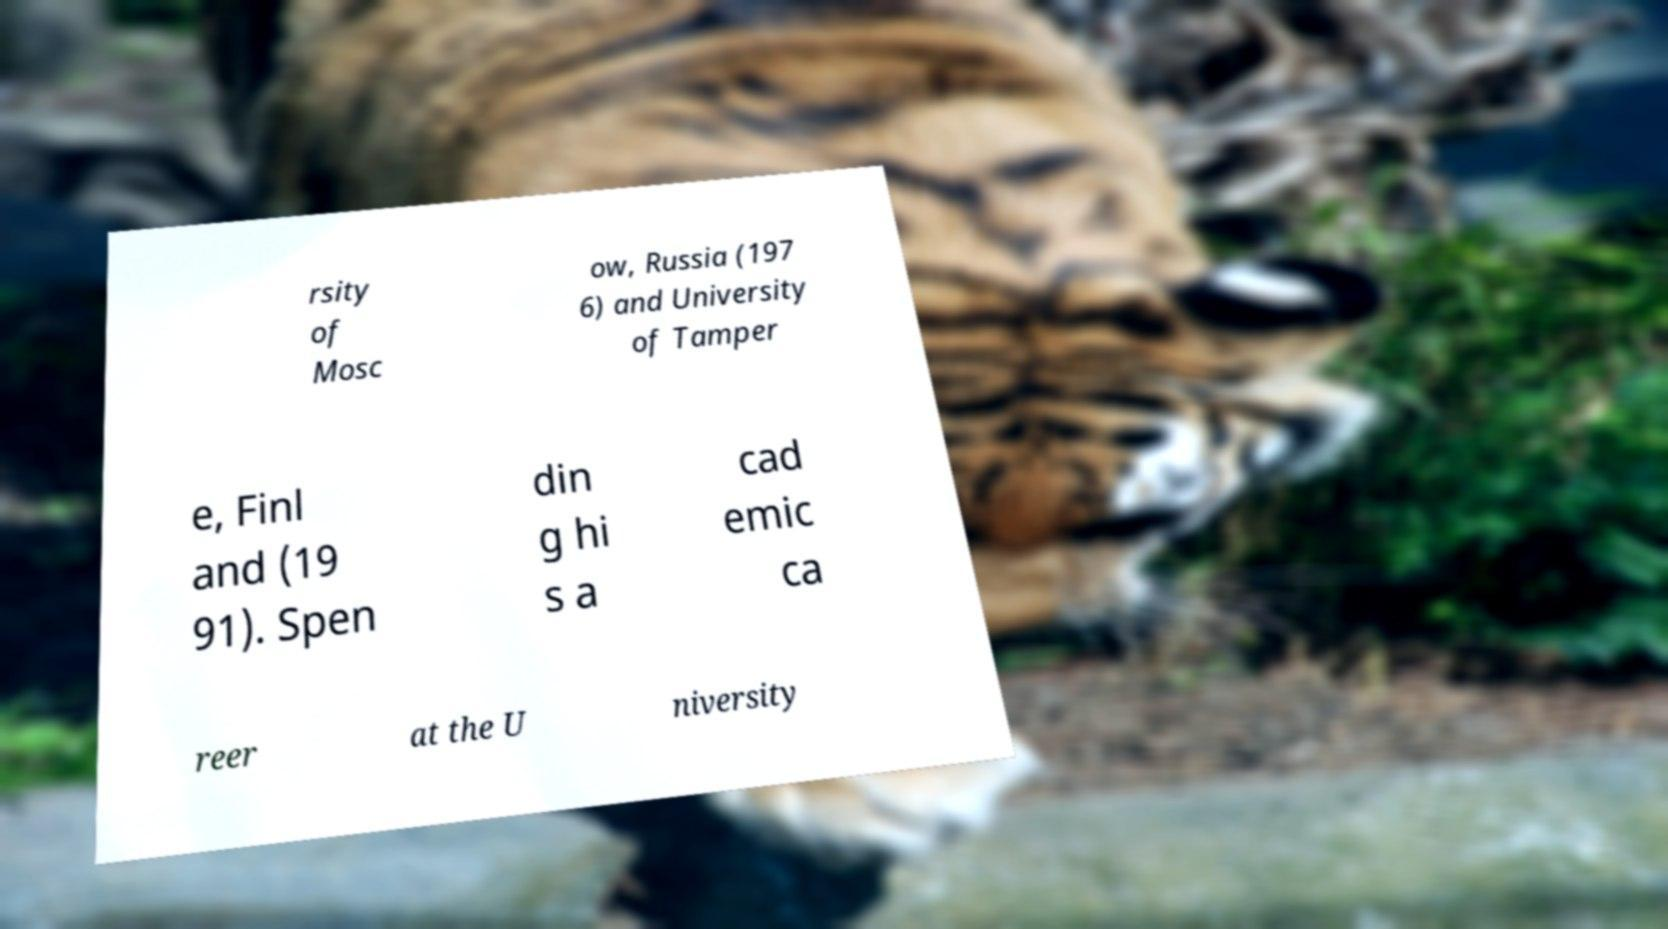What messages or text are displayed in this image? I need them in a readable, typed format. rsity of Mosc ow, Russia (197 6) and University of Tamper e, Finl and (19 91). Spen din g hi s a cad emic ca reer at the U niversity 